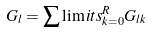Convert formula to latex. <formula><loc_0><loc_0><loc_500><loc_500>G _ { l } = \sum \lim i t s _ { k = 0 } ^ { R } G _ { l k }</formula> 